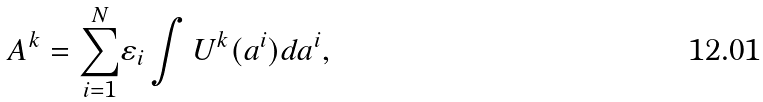Convert formula to latex. <formula><loc_0><loc_0><loc_500><loc_500>A ^ { k } = \underset { i = 1 } { \overset { N } { \sum } } \varepsilon _ { i } \int U ^ { k } ( a ^ { i } ) d a ^ { i } ,</formula> 